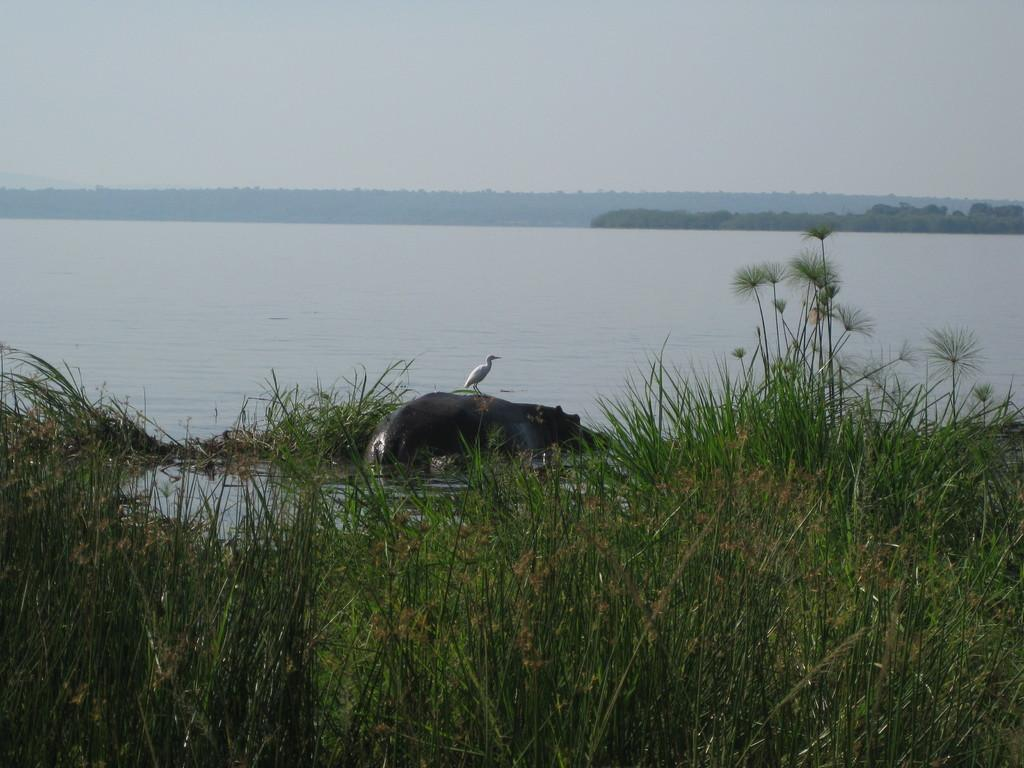What type of animal is in the image? There is an animal in the image, but its specific type cannot be determined from the provided facts. What color is the animal in the image? The animal is black in color. What is on top of the animal in the image? There is a bird on the animal. What type of vegetation is visible in the image? There is grass visible in the image. What type of water feature is visible in the image? There is water visible in the image. What type of landform is visible in the image? There is a hill visible in the image. What part of the natural environment is visible in the image? The sky is visible in the image. Where is the pest hiding on the shelf in the image? There is no shelf or pest present in the image. 